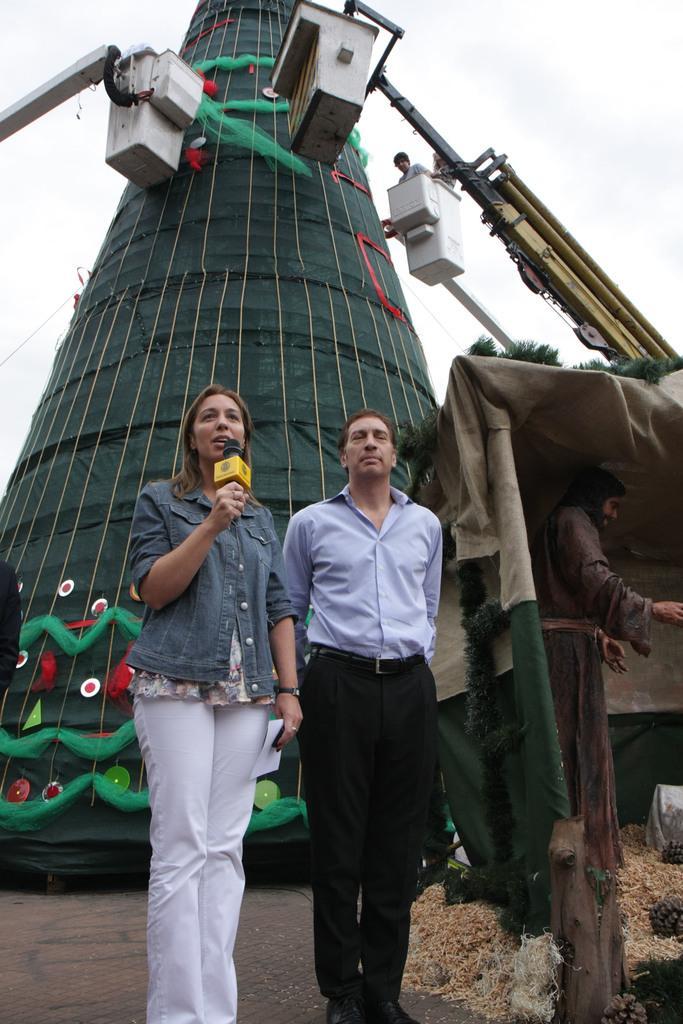Could you give a brief overview of what you see in this image? In this image I can see a woman wearing blue and white colored dress and a man wearing shirt and black colored pant are standing and I can see a woman is holding a microphone in her hand. In the background I can see few cranes, a person standing in the crane, a huge green colored structure, a statue, a tent and the sky. 